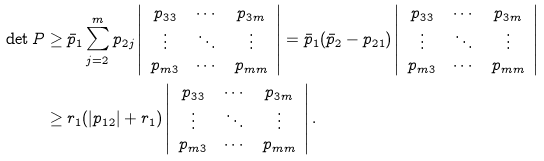Convert formula to latex. <formula><loc_0><loc_0><loc_500><loc_500>\det P & \geq \bar { p } _ { 1 } \sum _ { j = 2 } ^ { m } p _ { 2 j } \left | \begin{array} { c c c } p _ { 3 3 } & \cdots & p _ { 3 m } \\ \vdots & \ddots & \vdots \\ p _ { m 3 } & \cdots & p _ { m m } \\ \end{array} \right | = \bar { p } _ { 1 } ( \bar { p } _ { 2 } - p _ { 2 1 } ) \left | \begin{array} { c c c } p _ { 3 3 } & \cdots & p _ { 3 m } \\ \vdots & \ddots & \vdots \\ p _ { m 3 } & \cdots & p _ { m m } \\ \end{array} \right | \\ & \geq r _ { 1 } ( | p _ { 1 2 } | + r _ { 1 } ) \left | \begin{array} { c c c } p _ { 3 3 } & \cdots & p _ { 3 m } \\ \vdots & \ddots & \vdots \\ p _ { m 3 } & \cdots & p _ { m m } \\ \end{array} \right | .</formula> 